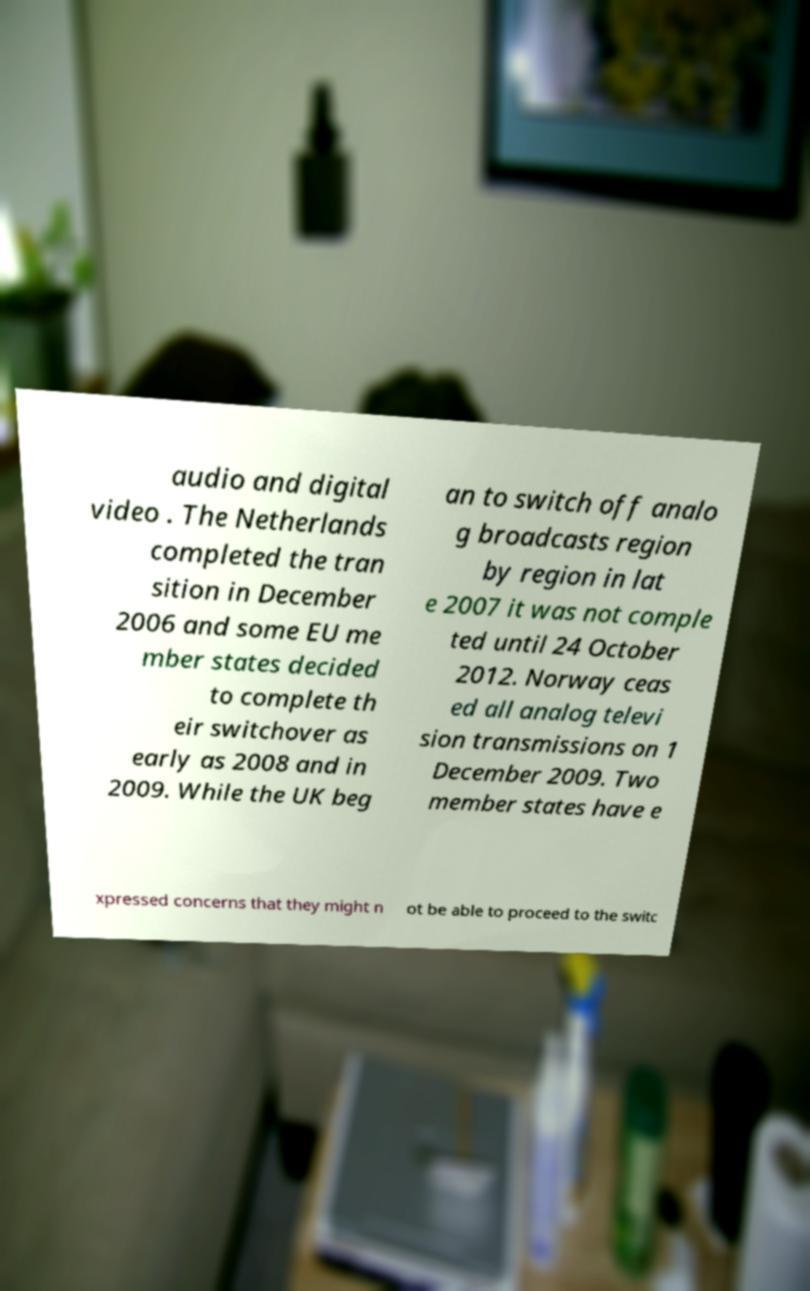There's text embedded in this image that I need extracted. Can you transcribe it verbatim? audio and digital video . The Netherlands completed the tran sition in December 2006 and some EU me mber states decided to complete th eir switchover as early as 2008 and in 2009. While the UK beg an to switch off analo g broadcasts region by region in lat e 2007 it was not comple ted until 24 October 2012. Norway ceas ed all analog televi sion transmissions on 1 December 2009. Two member states have e xpressed concerns that they might n ot be able to proceed to the switc 